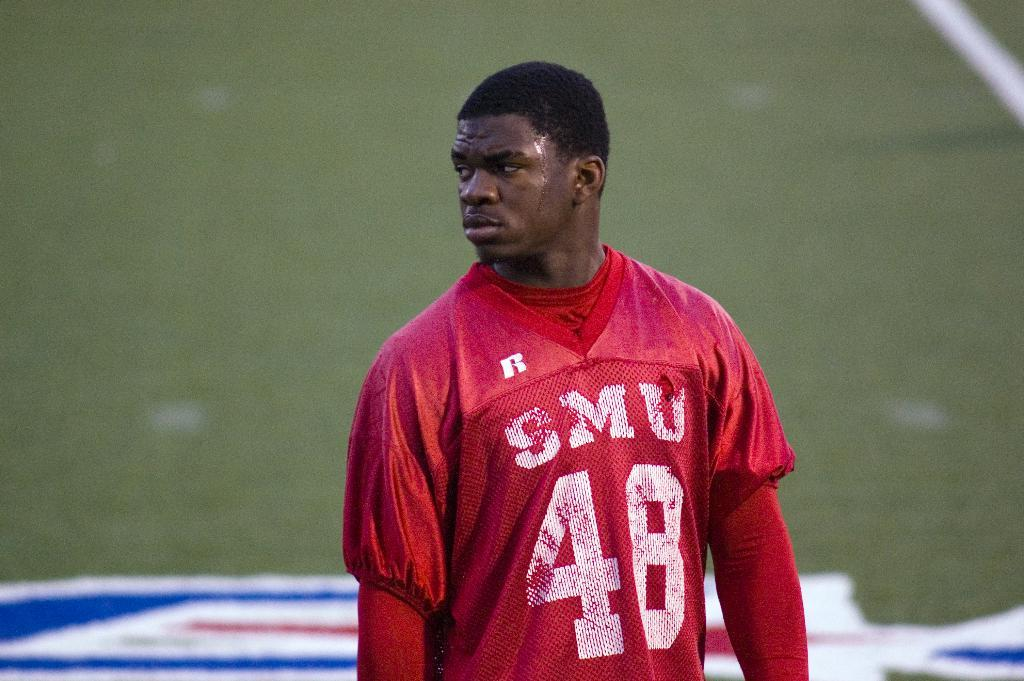Provide a one-sentence caption for the provided image. SMU player number forty eight stands on the field wearing a red jersey. 